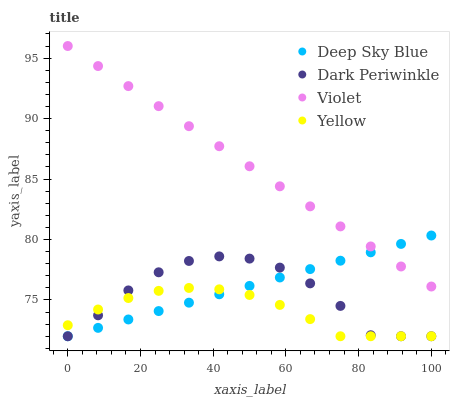Does Yellow have the minimum area under the curve?
Answer yes or no. Yes. Does Violet have the maximum area under the curve?
Answer yes or no. Yes. Does Dark Periwinkle have the minimum area under the curve?
Answer yes or no. No. Does Dark Periwinkle have the maximum area under the curve?
Answer yes or no. No. Is Deep Sky Blue the smoothest?
Answer yes or no. Yes. Is Dark Periwinkle the roughest?
Answer yes or no. Yes. Is Dark Periwinkle the smoothest?
Answer yes or no. No. Is Deep Sky Blue the roughest?
Answer yes or no. No. Does Yellow have the lowest value?
Answer yes or no. Yes. Does Violet have the lowest value?
Answer yes or no. No. Does Violet have the highest value?
Answer yes or no. Yes. Does Dark Periwinkle have the highest value?
Answer yes or no. No. Is Dark Periwinkle less than Violet?
Answer yes or no. Yes. Is Violet greater than Yellow?
Answer yes or no. Yes. Does Violet intersect Deep Sky Blue?
Answer yes or no. Yes. Is Violet less than Deep Sky Blue?
Answer yes or no. No. Is Violet greater than Deep Sky Blue?
Answer yes or no. No. Does Dark Periwinkle intersect Violet?
Answer yes or no. No. 